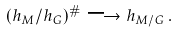<formula> <loc_0><loc_0><loc_500><loc_500>( h _ { M } / h _ { G } ) ^ { \# } \longrightarrow h _ { M / G } \, .</formula> 